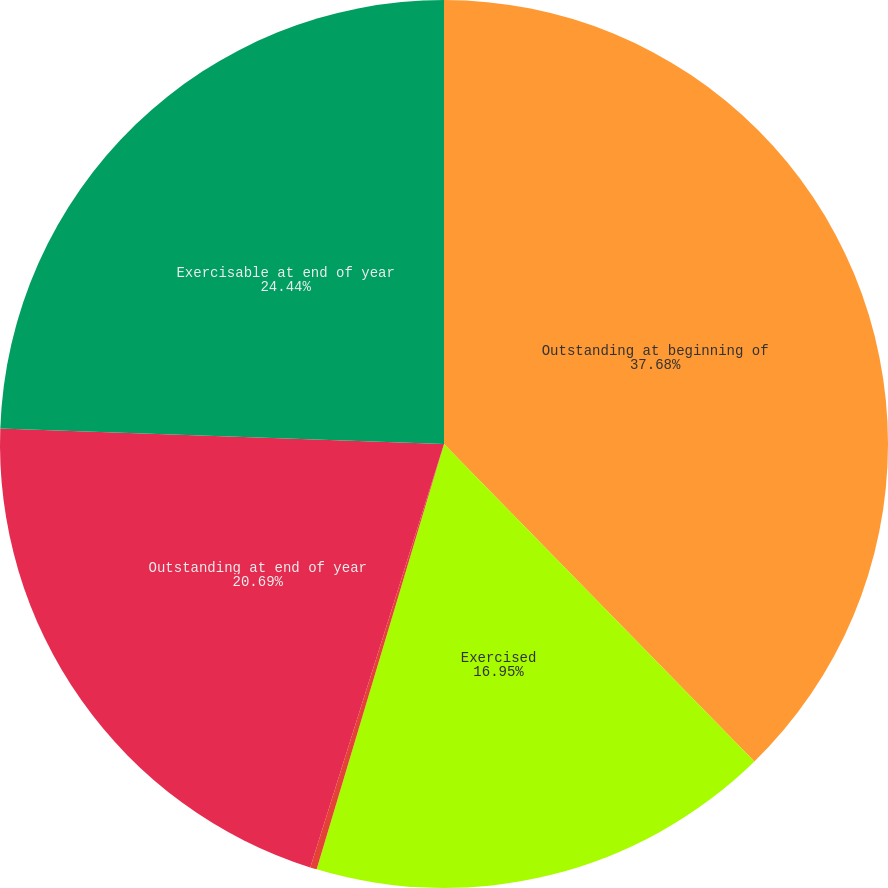<chart> <loc_0><loc_0><loc_500><loc_500><pie_chart><fcel>Outstanding at beginning of<fcel>Exercised<fcel>Cancelled or expired<fcel>Outstanding at end of year<fcel>Exercisable at end of year<nl><fcel>37.68%<fcel>16.95%<fcel>0.24%<fcel>20.69%<fcel>24.44%<nl></chart> 